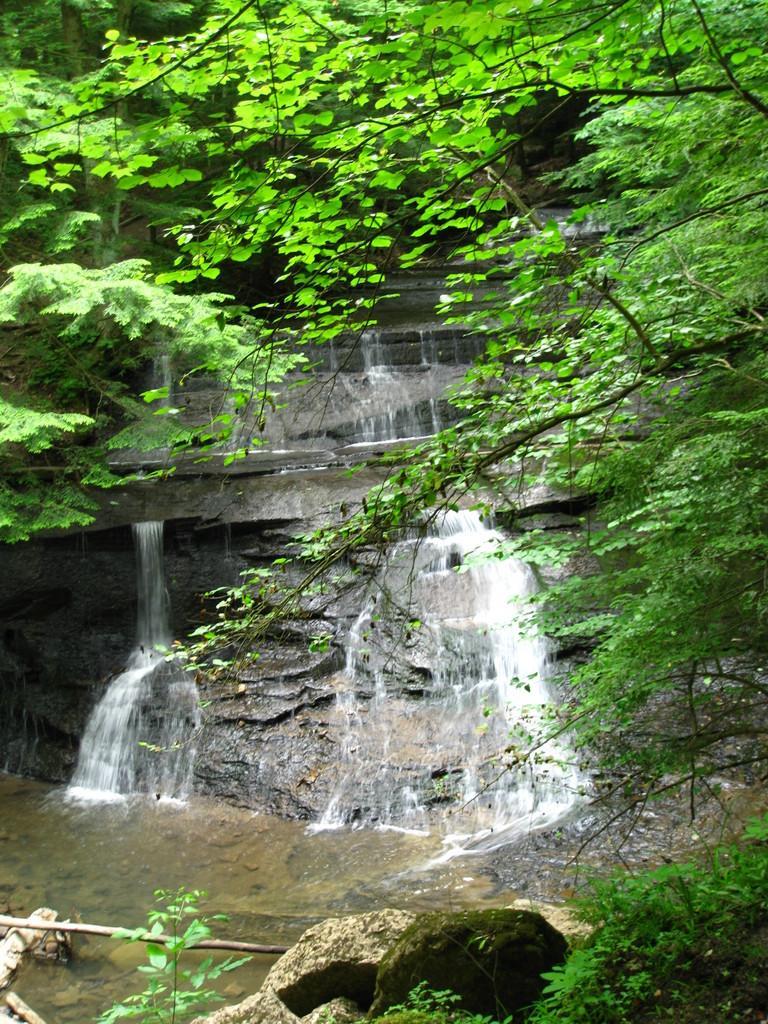Please provide a concise description of this image. In the foreground of this image, there are trees, water and the rocks. In the background, there is a waterfall and the trees. 